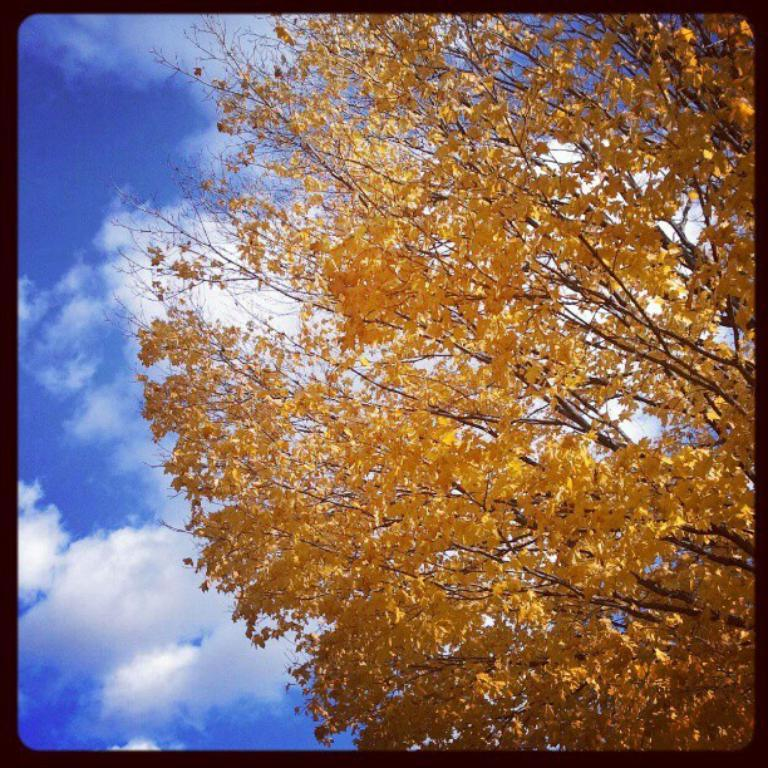What is located on the right side of the image in the foreground? There is a tree in the foreground of the image, on the right side. What can be seen in the background of the image? The sky is visible in the background of the image. Can you describe the sky in the image? There is a cloud in the sky. What type of camera is being used to take the picture of the tree and sky? There is no information about a camera being used to take the picture, as the focus is on the objects in the image. 